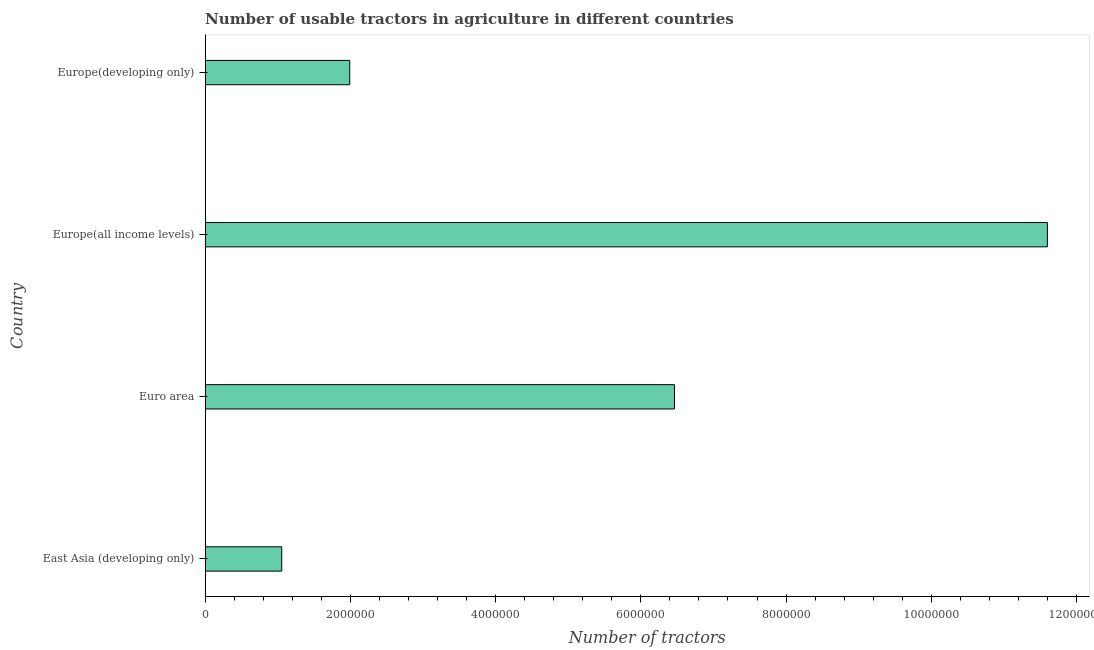Does the graph contain any zero values?
Your answer should be compact. No. Does the graph contain grids?
Make the answer very short. No. What is the title of the graph?
Give a very brief answer. Number of usable tractors in agriculture in different countries. What is the label or title of the X-axis?
Provide a short and direct response. Number of tractors. What is the label or title of the Y-axis?
Your answer should be very brief. Country. What is the number of tractors in East Asia (developing only)?
Your response must be concise. 1.05e+06. Across all countries, what is the maximum number of tractors?
Keep it short and to the point. 1.16e+07. Across all countries, what is the minimum number of tractors?
Offer a terse response. 1.05e+06. In which country was the number of tractors maximum?
Provide a succinct answer. Europe(all income levels). In which country was the number of tractors minimum?
Ensure brevity in your answer.  East Asia (developing only). What is the sum of the number of tractors?
Your answer should be very brief. 2.11e+07. What is the difference between the number of tractors in East Asia (developing only) and Europe(developing only)?
Your response must be concise. -9.37e+05. What is the average number of tractors per country?
Give a very brief answer. 5.28e+06. What is the median number of tractors?
Keep it short and to the point. 4.23e+06. In how many countries, is the number of tractors greater than 8000000 ?
Your response must be concise. 1. What is the ratio of the number of tractors in East Asia (developing only) to that in Europe(developing only)?
Offer a terse response. 0.53. Is the difference between the number of tractors in East Asia (developing only) and Europe(all income levels) greater than the difference between any two countries?
Provide a succinct answer. Yes. What is the difference between the highest and the second highest number of tractors?
Keep it short and to the point. 5.14e+06. What is the difference between the highest and the lowest number of tractors?
Provide a short and direct response. 1.05e+07. Are all the bars in the graph horizontal?
Provide a succinct answer. Yes. Are the values on the major ticks of X-axis written in scientific E-notation?
Offer a terse response. No. What is the Number of tractors of East Asia (developing only)?
Give a very brief answer. 1.05e+06. What is the Number of tractors in Euro area?
Provide a succinct answer. 6.46e+06. What is the Number of tractors of Europe(all income levels)?
Keep it short and to the point. 1.16e+07. What is the Number of tractors of Europe(developing only)?
Offer a very short reply. 1.99e+06. What is the difference between the Number of tractors in East Asia (developing only) and Euro area?
Your answer should be compact. -5.41e+06. What is the difference between the Number of tractors in East Asia (developing only) and Europe(all income levels)?
Provide a succinct answer. -1.05e+07. What is the difference between the Number of tractors in East Asia (developing only) and Europe(developing only)?
Give a very brief answer. -9.37e+05. What is the difference between the Number of tractors in Euro area and Europe(all income levels)?
Ensure brevity in your answer.  -5.14e+06. What is the difference between the Number of tractors in Euro area and Europe(developing only)?
Keep it short and to the point. 4.47e+06. What is the difference between the Number of tractors in Europe(all income levels) and Europe(developing only)?
Ensure brevity in your answer.  9.61e+06. What is the ratio of the Number of tractors in East Asia (developing only) to that in Euro area?
Make the answer very short. 0.16. What is the ratio of the Number of tractors in East Asia (developing only) to that in Europe(all income levels)?
Offer a terse response. 0.09. What is the ratio of the Number of tractors in East Asia (developing only) to that in Europe(developing only)?
Provide a short and direct response. 0.53. What is the ratio of the Number of tractors in Euro area to that in Europe(all income levels)?
Your answer should be very brief. 0.56. What is the ratio of the Number of tractors in Euro area to that in Europe(developing only)?
Your answer should be very brief. 3.25. What is the ratio of the Number of tractors in Europe(all income levels) to that in Europe(developing only)?
Provide a succinct answer. 5.83. 